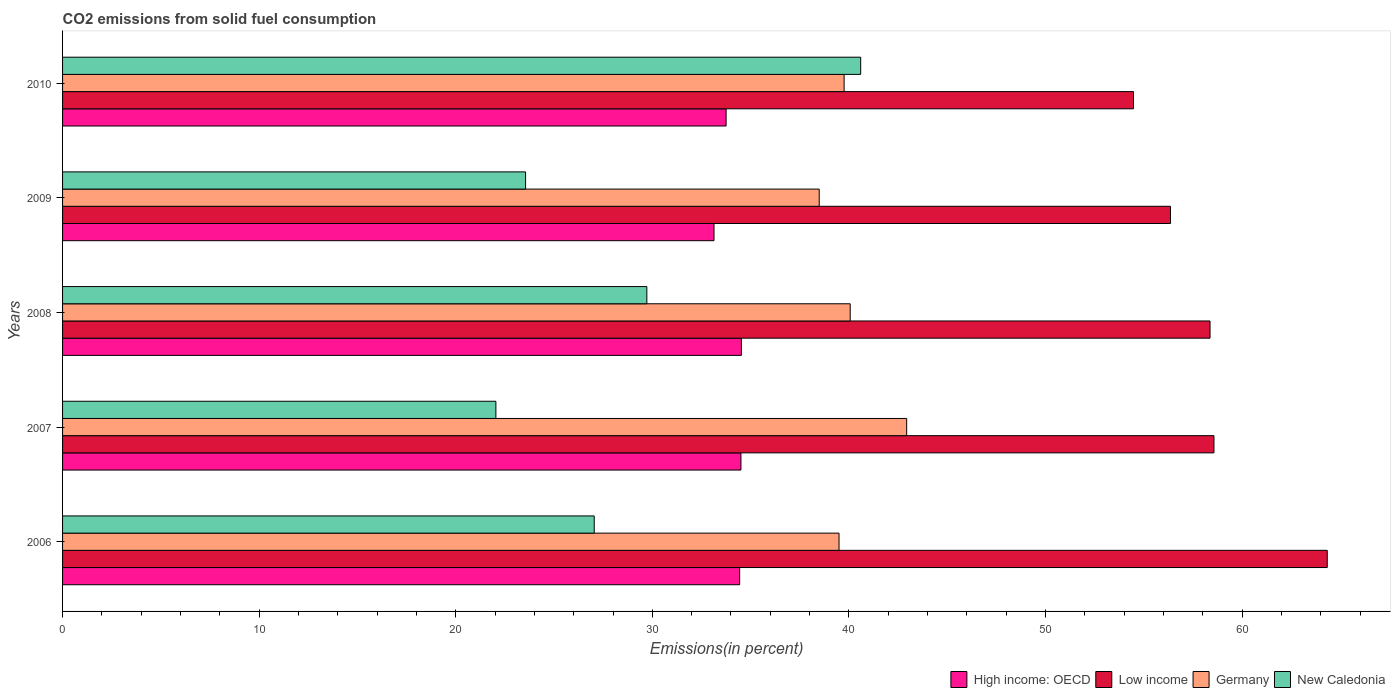Are the number of bars on each tick of the Y-axis equal?
Offer a very short reply. Yes. In how many cases, is the number of bars for a given year not equal to the number of legend labels?
Provide a short and direct response. 0. What is the total CO2 emitted in Germany in 2008?
Provide a short and direct response. 40.07. Across all years, what is the maximum total CO2 emitted in New Caledonia?
Offer a very short reply. 40.6. Across all years, what is the minimum total CO2 emitted in Germany?
Provide a short and direct response. 38.49. What is the total total CO2 emitted in High income: OECD in the graph?
Give a very brief answer. 170.37. What is the difference between the total CO2 emitted in High income: OECD in 2009 and that in 2010?
Provide a short and direct response. -0.62. What is the difference between the total CO2 emitted in New Caledonia in 2010 and the total CO2 emitted in Low income in 2009?
Your response must be concise. -15.76. What is the average total CO2 emitted in Low income per year?
Offer a terse response. 58.42. In the year 2010, what is the difference between the total CO2 emitted in Germany and total CO2 emitted in New Caledonia?
Provide a succinct answer. -0.84. What is the ratio of the total CO2 emitted in High income: OECD in 2007 to that in 2008?
Your answer should be very brief. 1. Is the total CO2 emitted in Germany in 2007 less than that in 2008?
Your response must be concise. No. Is the difference between the total CO2 emitted in Germany in 2007 and 2009 greater than the difference between the total CO2 emitted in New Caledonia in 2007 and 2009?
Offer a terse response. Yes. What is the difference between the highest and the second highest total CO2 emitted in High income: OECD?
Provide a succinct answer. 0.02. What is the difference between the highest and the lowest total CO2 emitted in New Caledonia?
Offer a very short reply. 18.56. Is the sum of the total CO2 emitted in Germany in 2006 and 2009 greater than the maximum total CO2 emitted in Low income across all years?
Make the answer very short. Yes. What does the 1st bar from the top in 2007 represents?
Provide a succinct answer. New Caledonia. Is it the case that in every year, the sum of the total CO2 emitted in Germany and total CO2 emitted in High income: OECD is greater than the total CO2 emitted in New Caledonia?
Keep it short and to the point. Yes. Are all the bars in the graph horizontal?
Provide a succinct answer. Yes. How many years are there in the graph?
Offer a terse response. 5. Does the graph contain any zero values?
Your answer should be very brief. No. Does the graph contain grids?
Your answer should be very brief. No. Where does the legend appear in the graph?
Your answer should be compact. Bottom right. How many legend labels are there?
Your answer should be very brief. 4. What is the title of the graph?
Provide a succinct answer. CO2 emissions from solid fuel consumption. What is the label or title of the X-axis?
Your answer should be compact. Emissions(in percent). What is the Emissions(in percent) in High income: OECD in 2006?
Give a very brief answer. 34.44. What is the Emissions(in percent) in Low income in 2006?
Ensure brevity in your answer.  64.33. What is the Emissions(in percent) in Germany in 2006?
Make the answer very short. 39.5. What is the Emissions(in percent) in New Caledonia in 2006?
Make the answer very short. 27.04. What is the Emissions(in percent) in High income: OECD in 2007?
Make the answer very short. 34.51. What is the Emissions(in percent) of Low income in 2007?
Your answer should be compact. 58.57. What is the Emissions(in percent) of Germany in 2007?
Offer a terse response. 42.94. What is the Emissions(in percent) of New Caledonia in 2007?
Give a very brief answer. 22.04. What is the Emissions(in percent) of High income: OECD in 2008?
Make the answer very short. 34.53. What is the Emissions(in percent) in Low income in 2008?
Offer a terse response. 58.37. What is the Emissions(in percent) of Germany in 2008?
Offer a terse response. 40.07. What is the Emissions(in percent) in New Caledonia in 2008?
Provide a succinct answer. 29.72. What is the Emissions(in percent) in High income: OECD in 2009?
Offer a very short reply. 33.14. What is the Emissions(in percent) of Low income in 2009?
Your response must be concise. 56.36. What is the Emissions(in percent) of Germany in 2009?
Offer a terse response. 38.49. What is the Emissions(in percent) of New Caledonia in 2009?
Give a very brief answer. 23.55. What is the Emissions(in percent) of High income: OECD in 2010?
Provide a short and direct response. 33.75. What is the Emissions(in percent) of Low income in 2010?
Your response must be concise. 54.48. What is the Emissions(in percent) of Germany in 2010?
Your answer should be compact. 39.75. What is the Emissions(in percent) of New Caledonia in 2010?
Your answer should be compact. 40.6. Across all years, what is the maximum Emissions(in percent) of High income: OECD?
Ensure brevity in your answer.  34.53. Across all years, what is the maximum Emissions(in percent) in Low income?
Provide a succinct answer. 64.33. Across all years, what is the maximum Emissions(in percent) of Germany?
Ensure brevity in your answer.  42.94. Across all years, what is the maximum Emissions(in percent) of New Caledonia?
Your answer should be very brief. 40.6. Across all years, what is the minimum Emissions(in percent) of High income: OECD?
Provide a short and direct response. 33.14. Across all years, what is the minimum Emissions(in percent) of Low income?
Ensure brevity in your answer.  54.48. Across all years, what is the minimum Emissions(in percent) in Germany?
Provide a short and direct response. 38.49. Across all years, what is the minimum Emissions(in percent) in New Caledonia?
Your response must be concise. 22.04. What is the total Emissions(in percent) of High income: OECD in the graph?
Ensure brevity in your answer.  170.37. What is the total Emissions(in percent) in Low income in the graph?
Provide a succinct answer. 292.1. What is the total Emissions(in percent) in Germany in the graph?
Your response must be concise. 200.74. What is the total Emissions(in percent) of New Caledonia in the graph?
Offer a terse response. 142.96. What is the difference between the Emissions(in percent) in High income: OECD in 2006 and that in 2007?
Ensure brevity in your answer.  -0.06. What is the difference between the Emissions(in percent) in Low income in 2006 and that in 2007?
Provide a short and direct response. 5.76. What is the difference between the Emissions(in percent) in Germany in 2006 and that in 2007?
Your answer should be compact. -3.44. What is the difference between the Emissions(in percent) of New Caledonia in 2006 and that in 2007?
Provide a short and direct response. 5. What is the difference between the Emissions(in percent) of High income: OECD in 2006 and that in 2008?
Your response must be concise. -0.09. What is the difference between the Emissions(in percent) in Low income in 2006 and that in 2008?
Your response must be concise. 5.96. What is the difference between the Emissions(in percent) in Germany in 2006 and that in 2008?
Your response must be concise. -0.57. What is the difference between the Emissions(in percent) in New Caledonia in 2006 and that in 2008?
Your answer should be compact. -2.68. What is the difference between the Emissions(in percent) of High income: OECD in 2006 and that in 2009?
Offer a very short reply. 1.3. What is the difference between the Emissions(in percent) in Low income in 2006 and that in 2009?
Give a very brief answer. 7.97. What is the difference between the Emissions(in percent) of Germany in 2006 and that in 2009?
Your answer should be very brief. 1.01. What is the difference between the Emissions(in percent) of New Caledonia in 2006 and that in 2009?
Ensure brevity in your answer.  3.49. What is the difference between the Emissions(in percent) of High income: OECD in 2006 and that in 2010?
Give a very brief answer. 0.69. What is the difference between the Emissions(in percent) in Low income in 2006 and that in 2010?
Your answer should be very brief. 9.86. What is the difference between the Emissions(in percent) in Germany in 2006 and that in 2010?
Give a very brief answer. -0.26. What is the difference between the Emissions(in percent) of New Caledonia in 2006 and that in 2010?
Provide a succinct answer. -13.55. What is the difference between the Emissions(in percent) in High income: OECD in 2007 and that in 2008?
Ensure brevity in your answer.  -0.02. What is the difference between the Emissions(in percent) of Low income in 2007 and that in 2008?
Offer a terse response. 0.2. What is the difference between the Emissions(in percent) of Germany in 2007 and that in 2008?
Your answer should be very brief. 2.87. What is the difference between the Emissions(in percent) of New Caledonia in 2007 and that in 2008?
Offer a very short reply. -7.68. What is the difference between the Emissions(in percent) in High income: OECD in 2007 and that in 2009?
Provide a short and direct response. 1.37. What is the difference between the Emissions(in percent) of Low income in 2007 and that in 2009?
Keep it short and to the point. 2.21. What is the difference between the Emissions(in percent) in Germany in 2007 and that in 2009?
Provide a short and direct response. 4.45. What is the difference between the Emissions(in percent) of New Caledonia in 2007 and that in 2009?
Provide a succinct answer. -1.51. What is the difference between the Emissions(in percent) of High income: OECD in 2007 and that in 2010?
Offer a very short reply. 0.75. What is the difference between the Emissions(in percent) in Low income in 2007 and that in 2010?
Provide a short and direct response. 4.09. What is the difference between the Emissions(in percent) of Germany in 2007 and that in 2010?
Your response must be concise. 3.18. What is the difference between the Emissions(in percent) in New Caledonia in 2007 and that in 2010?
Your answer should be very brief. -18.56. What is the difference between the Emissions(in percent) of High income: OECD in 2008 and that in 2009?
Your response must be concise. 1.39. What is the difference between the Emissions(in percent) of Low income in 2008 and that in 2009?
Your answer should be compact. 2.01. What is the difference between the Emissions(in percent) of Germany in 2008 and that in 2009?
Keep it short and to the point. 1.58. What is the difference between the Emissions(in percent) in New Caledonia in 2008 and that in 2009?
Ensure brevity in your answer.  6.17. What is the difference between the Emissions(in percent) in High income: OECD in 2008 and that in 2010?
Keep it short and to the point. 0.78. What is the difference between the Emissions(in percent) in Low income in 2008 and that in 2010?
Give a very brief answer. 3.89. What is the difference between the Emissions(in percent) of Germany in 2008 and that in 2010?
Make the answer very short. 0.31. What is the difference between the Emissions(in percent) of New Caledonia in 2008 and that in 2010?
Your response must be concise. -10.88. What is the difference between the Emissions(in percent) of High income: OECD in 2009 and that in 2010?
Provide a succinct answer. -0.62. What is the difference between the Emissions(in percent) of Low income in 2009 and that in 2010?
Make the answer very short. 1.88. What is the difference between the Emissions(in percent) of Germany in 2009 and that in 2010?
Keep it short and to the point. -1.27. What is the difference between the Emissions(in percent) of New Caledonia in 2009 and that in 2010?
Give a very brief answer. -17.05. What is the difference between the Emissions(in percent) in High income: OECD in 2006 and the Emissions(in percent) in Low income in 2007?
Your response must be concise. -24.13. What is the difference between the Emissions(in percent) in High income: OECD in 2006 and the Emissions(in percent) in Germany in 2007?
Provide a short and direct response. -8.49. What is the difference between the Emissions(in percent) in Low income in 2006 and the Emissions(in percent) in Germany in 2007?
Offer a terse response. 21.39. What is the difference between the Emissions(in percent) in Low income in 2006 and the Emissions(in percent) in New Caledonia in 2007?
Offer a very short reply. 42.29. What is the difference between the Emissions(in percent) of Germany in 2006 and the Emissions(in percent) of New Caledonia in 2007?
Provide a succinct answer. 17.45. What is the difference between the Emissions(in percent) of High income: OECD in 2006 and the Emissions(in percent) of Low income in 2008?
Offer a terse response. -23.93. What is the difference between the Emissions(in percent) in High income: OECD in 2006 and the Emissions(in percent) in Germany in 2008?
Your answer should be very brief. -5.62. What is the difference between the Emissions(in percent) of High income: OECD in 2006 and the Emissions(in percent) of New Caledonia in 2008?
Provide a succinct answer. 4.72. What is the difference between the Emissions(in percent) in Low income in 2006 and the Emissions(in percent) in Germany in 2008?
Your answer should be compact. 24.27. What is the difference between the Emissions(in percent) of Low income in 2006 and the Emissions(in percent) of New Caledonia in 2008?
Give a very brief answer. 34.61. What is the difference between the Emissions(in percent) of Germany in 2006 and the Emissions(in percent) of New Caledonia in 2008?
Keep it short and to the point. 9.78. What is the difference between the Emissions(in percent) of High income: OECD in 2006 and the Emissions(in percent) of Low income in 2009?
Offer a terse response. -21.91. What is the difference between the Emissions(in percent) in High income: OECD in 2006 and the Emissions(in percent) in Germany in 2009?
Make the answer very short. -4.05. What is the difference between the Emissions(in percent) of High income: OECD in 2006 and the Emissions(in percent) of New Caledonia in 2009?
Keep it short and to the point. 10.89. What is the difference between the Emissions(in percent) of Low income in 2006 and the Emissions(in percent) of Germany in 2009?
Give a very brief answer. 25.84. What is the difference between the Emissions(in percent) in Low income in 2006 and the Emissions(in percent) in New Caledonia in 2009?
Your answer should be compact. 40.78. What is the difference between the Emissions(in percent) of Germany in 2006 and the Emissions(in percent) of New Caledonia in 2009?
Provide a short and direct response. 15.94. What is the difference between the Emissions(in percent) in High income: OECD in 2006 and the Emissions(in percent) in Low income in 2010?
Make the answer very short. -20.03. What is the difference between the Emissions(in percent) of High income: OECD in 2006 and the Emissions(in percent) of Germany in 2010?
Provide a succinct answer. -5.31. What is the difference between the Emissions(in percent) in High income: OECD in 2006 and the Emissions(in percent) in New Caledonia in 2010?
Your response must be concise. -6.16. What is the difference between the Emissions(in percent) of Low income in 2006 and the Emissions(in percent) of Germany in 2010?
Provide a short and direct response. 24.58. What is the difference between the Emissions(in percent) in Low income in 2006 and the Emissions(in percent) in New Caledonia in 2010?
Ensure brevity in your answer.  23.73. What is the difference between the Emissions(in percent) in Germany in 2006 and the Emissions(in percent) in New Caledonia in 2010?
Keep it short and to the point. -1.1. What is the difference between the Emissions(in percent) of High income: OECD in 2007 and the Emissions(in percent) of Low income in 2008?
Offer a terse response. -23.86. What is the difference between the Emissions(in percent) of High income: OECD in 2007 and the Emissions(in percent) of Germany in 2008?
Make the answer very short. -5.56. What is the difference between the Emissions(in percent) in High income: OECD in 2007 and the Emissions(in percent) in New Caledonia in 2008?
Offer a terse response. 4.79. What is the difference between the Emissions(in percent) in Low income in 2007 and the Emissions(in percent) in Germany in 2008?
Offer a very short reply. 18.5. What is the difference between the Emissions(in percent) in Low income in 2007 and the Emissions(in percent) in New Caledonia in 2008?
Your answer should be very brief. 28.85. What is the difference between the Emissions(in percent) of Germany in 2007 and the Emissions(in percent) of New Caledonia in 2008?
Your response must be concise. 13.22. What is the difference between the Emissions(in percent) of High income: OECD in 2007 and the Emissions(in percent) of Low income in 2009?
Provide a short and direct response. -21.85. What is the difference between the Emissions(in percent) of High income: OECD in 2007 and the Emissions(in percent) of Germany in 2009?
Make the answer very short. -3.98. What is the difference between the Emissions(in percent) in High income: OECD in 2007 and the Emissions(in percent) in New Caledonia in 2009?
Ensure brevity in your answer.  10.95. What is the difference between the Emissions(in percent) of Low income in 2007 and the Emissions(in percent) of Germany in 2009?
Provide a succinct answer. 20.08. What is the difference between the Emissions(in percent) in Low income in 2007 and the Emissions(in percent) in New Caledonia in 2009?
Your answer should be compact. 35.02. What is the difference between the Emissions(in percent) in Germany in 2007 and the Emissions(in percent) in New Caledonia in 2009?
Keep it short and to the point. 19.38. What is the difference between the Emissions(in percent) of High income: OECD in 2007 and the Emissions(in percent) of Low income in 2010?
Keep it short and to the point. -19.97. What is the difference between the Emissions(in percent) in High income: OECD in 2007 and the Emissions(in percent) in Germany in 2010?
Your answer should be very brief. -5.25. What is the difference between the Emissions(in percent) of High income: OECD in 2007 and the Emissions(in percent) of New Caledonia in 2010?
Your answer should be compact. -6.09. What is the difference between the Emissions(in percent) in Low income in 2007 and the Emissions(in percent) in Germany in 2010?
Provide a short and direct response. 18.81. What is the difference between the Emissions(in percent) of Low income in 2007 and the Emissions(in percent) of New Caledonia in 2010?
Your answer should be very brief. 17.97. What is the difference between the Emissions(in percent) in Germany in 2007 and the Emissions(in percent) in New Caledonia in 2010?
Give a very brief answer. 2.34. What is the difference between the Emissions(in percent) in High income: OECD in 2008 and the Emissions(in percent) in Low income in 2009?
Offer a very short reply. -21.83. What is the difference between the Emissions(in percent) in High income: OECD in 2008 and the Emissions(in percent) in Germany in 2009?
Offer a very short reply. -3.96. What is the difference between the Emissions(in percent) of High income: OECD in 2008 and the Emissions(in percent) of New Caledonia in 2009?
Offer a very short reply. 10.98. What is the difference between the Emissions(in percent) of Low income in 2008 and the Emissions(in percent) of Germany in 2009?
Offer a terse response. 19.88. What is the difference between the Emissions(in percent) in Low income in 2008 and the Emissions(in percent) in New Caledonia in 2009?
Make the answer very short. 34.82. What is the difference between the Emissions(in percent) of Germany in 2008 and the Emissions(in percent) of New Caledonia in 2009?
Offer a very short reply. 16.51. What is the difference between the Emissions(in percent) of High income: OECD in 2008 and the Emissions(in percent) of Low income in 2010?
Your response must be concise. -19.95. What is the difference between the Emissions(in percent) in High income: OECD in 2008 and the Emissions(in percent) in Germany in 2010?
Provide a short and direct response. -5.23. What is the difference between the Emissions(in percent) of High income: OECD in 2008 and the Emissions(in percent) of New Caledonia in 2010?
Give a very brief answer. -6.07. What is the difference between the Emissions(in percent) of Low income in 2008 and the Emissions(in percent) of Germany in 2010?
Ensure brevity in your answer.  18.61. What is the difference between the Emissions(in percent) of Low income in 2008 and the Emissions(in percent) of New Caledonia in 2010?
Your response must be concise. 17.77. What is the difference between the Emissions(in percent) of Germany in 2008 and the Emissions(in percent) of New Caledonia in 2010?
Offer a very short reply. -0.53. What is the difference between the Emissions(in percent) in High income: OECD in 2009 and the Emissions(in percent) in Low income in 2010?
Offer a very short reply. -21.34. What is the difference between the Emissions(in percent) of High income: OECD in 2009 and the Emissions(in percent) of Germany in 2010?
Your answer should be very brief. -6.62. What is the difference between the Emissions(in percent) in High income: OECD in 2009 and the Emissions(in percent) in New Caledonia in 2010?
Your response must be concise. -7.46. What is the difference between the Emissions(in percent) in Low income in 2009 and the Emissions(in percent) in Germany in 2010?
Your answer should be very brief. 16.6. What is the difference between the Emissions(in percent) in Low income in 2009 and the Emissions(in percent) in New Caledonia in 2010?
Give a very brief answer. 15.76. What is the difference between the Emissions(in percent) of Germany in 2009 and the Emissions(in percent) of New Caledonia in 2010?
Ensure brevity in your answer.  -2.11. What is the average Emissions(in percent) of High income: OECD per year?
Your answer should be compact. 34.07. What is the average Emissions(in percent) of Low income per year?
Keep it short and to the point. 58.42. What is the average Emissions(in percent) in Germany per year?
Ensure brevity in your answer.  40.15. What is the average Emissions(in percent) in New Caledonia per year?
Ensure brevity in your answer.  28.59. In the year 2006, what is the difference between the Emissions(in percent) of High income: OECD and Emissions(in percent) of Low income?
Offer a terse response. -29.89. In the year 2006, what is the difference between the Emissions(in percent) of High income: OECD and Emissions(in percent) of Germany?
Offer a very short reply. -5.05. In the year 2006, what is the difference between the Emissions(in percent) of High income: OECD and Emissions(in percent) of New Caledonia?
Ensure brevity in your answer.  7.4. In the year 2006, what is the difference between the Emissions(in percent) in Low income and Emissions(in percent) in Germany?
Your answer should be compact. 24.83. In the year 2006, what is the difference between the Emissions(in percent) in Low income and Emissions(in percent) in New Caledonia?
Keep it short and to the point. 37.29. In the year 2006, what is the difference between the Emissions(in percent) of Germany and Emissions(in percent) of New Caledonia?
Give a very brief answer. 12.45. In the year 2007, what is the difference between the Emissions(in percent) in High income: OECD and Emissions(in percent) in Low income?
Give a very brief answer. -24.06. In the year 2007, what is the difference between the Emissions(in percent) in High income: OECD and Emissions(in percent) in Germany?
Offer a terse response. -8.43. In the year 2007, what is the difference between the Emissions(in percent) in High income: OECD and Emissions(in percent) in New Caledonia?
Offer a terse response. 12.46. In the year 2007, what is the difference between the Emissions(in percent) in Low income and Emissions(in percent) in Germany?
Offer a very short reply. 15.63. In the year 2007, what is the difference between the Emissions(in percent) of Low income and Emissions(in percent) of New Caledonia?
Your answer should be very brief. 36.53. In the year 2007, what is the difference between the Emissions(in percent) of Germany and Emissions(in percent) of New Caledonia?
Provide a short and direct response. 20.89. In the year 2008, what is the difference between the Emissions(in percent) of High income: OECD and Emissions(in percent) of Low income?
Give a very brief answer. -23.84. In the year 2008, what is the difference between the Emissions(in percent) of High income: OECD and Emissions(in percent) of Germany?
Give a very brief answer. -5.54. In the year 2008, what is the difference between the Emissions(in percent) in High income: OECD and Emissions(in percent) in New Caledonia?
Give a very brief answer. 4.81. In the year 2008, what is the difference between the Emissions(in percent) in Low income and Emissions(in percent) in Germany?
Your answer should be very brief. 18.3. In the year 2008, what is the difference between the Emissions(in percent) of Low income and Emissions(in percent) of New Caledonia?
Give a very brief answer. 28.65. In the year 2008, what is the difference between the Emissions(in percent) in Germany and Emissions(in percent) in New Caledonia?
Give a very brief answer. 10.34. In the year 2009, what is the difference between the Emissions(in percent) of High income: OECD and Emissions(in percent) of Low income?
Make the answer very short. -23.22. In the year 2009, what is the difference between the Emissions(in percent) in High income: OECD and Emissions(in percent) in Germany?
Keep it short and to the point. -5.35. In the year 2009, what is the difference between the Emissions(in percent) in High income: OECD and Emissions(in percent) in New Caledonia?
Keep it short and to the point. 9.59. In the year 2009, what is the difference between the Emissions(in percent) in Low income and Emissions(in percent) in Germany?
Provide a succinct answer. 17.87. In the year 2009, what is the difference between the Emissions(in percent) in Low income and Emissions(in percent) in New Caledonia?
Provide a short and direct response. 32.8. In the year 2009, what is the difference between the Emissions(in percent) in Germany and Emissions(in percent) in New Caledonia?
Keep it short and to the point. 14.94. In the year 2010, what is the difference between the Emissions(in percent) of High income: OECD and Emissions(in percent) of Low income?
Ensure brevity in your answer.  -20.72. In the year 2010, what is the difference between the Emissions(in percent) in High income: OECD and Emissions(in percent) in Germany?
Provide a succinct answer. -6. In the year 2010, what is the difference between the Emissions(in percent) in High income: OECD and Emissions(in percent) in New Caledonia?
Your answer should be compact. -6.85. In the year 2010, what is the difference between the Emissions(in percent) of Low income and Emissions(in percent) of Germany?
Keep it short and to the point. 14.72. In the year 2010, what is the difference between the Emissions(in percent) of Low income and Emissions(in percent) of New Caledonia?
Give a very brief answer. 13.88. In the year 2010, what is the difference between the Emissions(in percent) in Germany and Emissions(in percent) in New Caledonia?
Make the answer very short. -0.84. What is the ratio of the Emissions(in percent) of High income: OECD in 2006 to that in 2007?
Provide a succinct answer. 1. What is the ratio of the Emissions(in percent) in Low income in 2006 to that in 2007?
Your answer should be compact. 1.1. What is the ratio of the Emissions(in percent) in Germany in 2006 to that in 2007?
Make the answer very short. 0.92. What is the ratio of the Emissions(in percent) of New Caledonia in 2006 to that in 2007?
Your answer should be very brief. 1.23. What is the ratio of the Emissions(in percent) of High income: OECD in 2006 to that in 2008?
Provide a short and direct response. 1. What is the ratio of the Emissions(in percent) in Low income in 2006 to that in 2008?
Your answer should be compact. 1.1. What is the ratio of the Emissions(in percent) in Germany in 2006 to that in 2008?
Give a very brief answer. 0.99. What is the ratio of the Emissions(in percent) in New Caledonia in 2006 to that in 2008?
Your response must be concise. 0.91. What is the ratio of the Emissions(in percent) of High income: OECD in 2006 to that in 2009?
Offer a terse response. 1.04. What is the ratio of the Emissions(in percent) of Low income in 2006 to that in 2009?
Your response must be concise. 1.14. What is the ratio of the Emissions(in percent) in Germany in 2006 to that in 2009?
Your answer should be compact. 1.03. What is the ratio of the Emissions(in percent) of New Caledonia in 2006 to that in 2009?
Your response must be concise. 1.15. What is the ratio of the Emissions(in percent) in High income: OECD in 2006 to that in 2010?
Give a very brief answer. 1.02. What is the ratio of the Emissions(in percent) in Low income in 2006 to that in 2010?
Offer a terse response. 1.18. What is the ratio of the Emissions(in percent) in New Caledonia in 2006 to that in 2010?
Provide a succinct answer. 0.67. What is the ratio of the Emissions(in percent) in Germany in 2007 to that in 2008?
Offer a terse response. 1.07. What is the ratio of the Emissions(in percent) in New Caledonia in 2007 to that in 2008?
Your answer should be compact. 0.74. What is the ratio of the Emissions(in percent) of High income: OECD in 2007 to that in 2009?
Make the answer very short. 1.04. What is the ratio of the Emissions(in percent) of Low income in 2007 to that in 2009?
Make the answer very short. 1.04. What is the ratio of the Emissions(in percent) of Germany in 2007 to that in 2009?
Make the answer very short. 1.12. What is the ratio of the Emissions(in percent) of New Caledonia in 2007 to that in 2009?
Offer a terse response. 0.94. What is the ratio of the Emissions(in percent) of High income: OECD in 2007 to that in 2010?
Give a very brief answer. 1.02. What is the ratio of the Emissions(in percent) in Low income in 2007 to that in 2010?
Provide a short and direct response. 1.08. What is the ratio of the Emissions(in percent) of New Caledonia in 2007 to that in 2010?
Keep it short and to the point. 0.54. What is the ratio of the Emissions(in percent) of High income: OECD in 2008 to that in 2009?
Your answer should be very brief. 1.04. What is the ratio of the Emissions(in percent) in Low income in 2008 to that in 2009?
Make the answer very short. 1.04. What is the ratio of the Emissions(in percent) in Germany in 2008 to that in 2009?
Provide a succinct answer. 1.04. What is the ratio of the Emissions(in percent) of New Caledonia in 2008 to that in 2009?
Provide a short and direct response. 1.26. What is the ratio of the Emissions(in percent) of High income: OECD in 2008 to that in 2010?
Your response must be concise. 1.02. What is the ratio of the Emissions(in percent) in Low income in 2008 to that in 2010?
Ensure brevity in your answer.  1.07. What is the ratio of the Emissions(in percent) of Germany in 2008 to that in 2010?
Provide a short and direct response. 1.01. What is the ratio of the Emissions(in percent) in New Caledonia in 2008 to that in 2010?
Keep it short and to the point. 0.73. What is the ratio of the Emissions(in percent) of High income: OECD in 2009 to that in 2010?
Keep it short and to the point. 0.98. What is the ratio of the Emissions(in percent) in Low income in 2009 to that in 2010?
Offer a very short reply. 1.03. What is the ratio of the Emissions(in percent) of Germany in 2009 to that in 2010?
Offer a terse response. 0.97. What is the ratio of the Emissions(in percent) in New Caledonia in 2009 to that in 2010?
Your answer should be compact. 0.58. What is the difference between the highest and the second highest Emissions(in percent) in High income: OECD?
Provide a short and direct response. 0.02. What is the difference between the highest and the second highest Emissions(in percent) of Low income?
Provide a short and direct response. 5.76. What is the difference between the highest and the second highest Emissions(in percent) of Germany?
Keep it short and to the point. 2.87. What is the difference between the highest and the second highest Emissions(in percent) of New Caledonia?
Your answer should be compact. 10.88. What is the difference between the highest and the lowest Emissions(in percent) in High income: OECD?
Provide a succinct answer. 1.39. What is the difference between the highest and the lowest Emissions(in percent) in Low income?
Provide a succinct answer. 9.86. What is the difference between the highest and the lowest Emissions(in percent) of Germany?
Provide a short and direct response. 4.45. What is the difference between the highest and the lowest Emissions(in percent) in New Caledonia?
Your answer should be very brief. 18.56. 